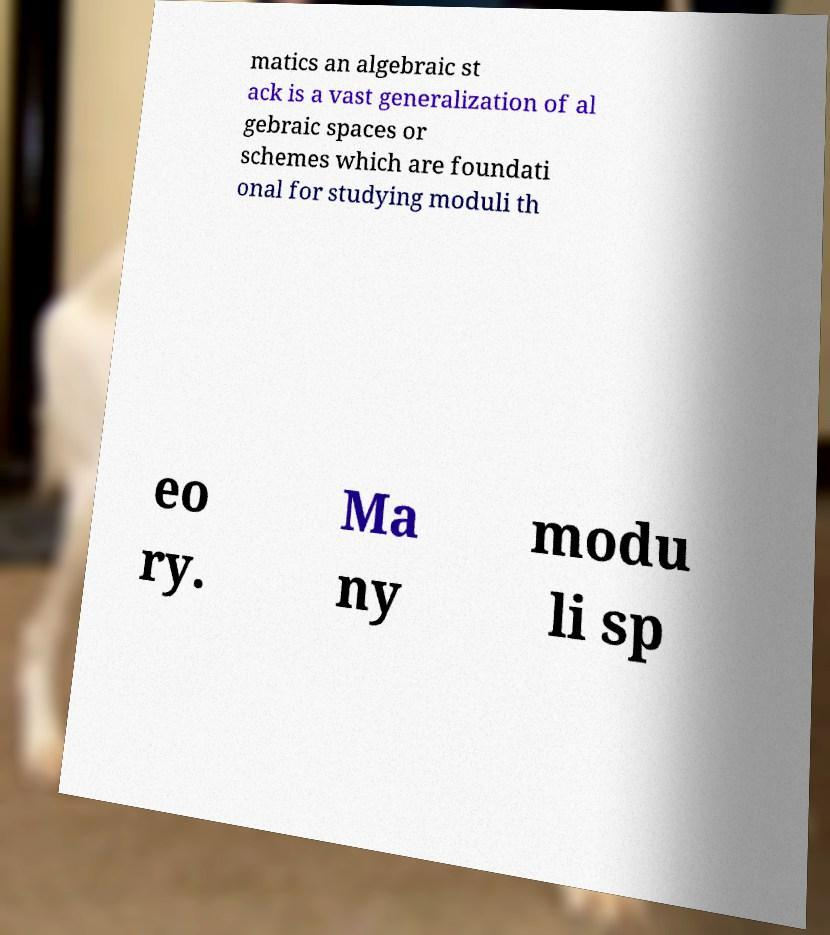Could you assist in decoding the text presented in this image and type it out clearly? matics an algebraic st ack is a vast generalization of al gebraic spaces or schemes which are foundati onal for studying moduli th eo ry. Ma ny modu li sp 